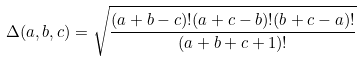<formula> <loc_0><loc_0><loc_500><loc_500>\Delta ( a , b , c ) = \sqrt { \frac { ( a + b - c ) ! ( a + c - b ) ! ( b + c - a ) ! } { ( a + b + c + 1 ) ! } }</formula> 